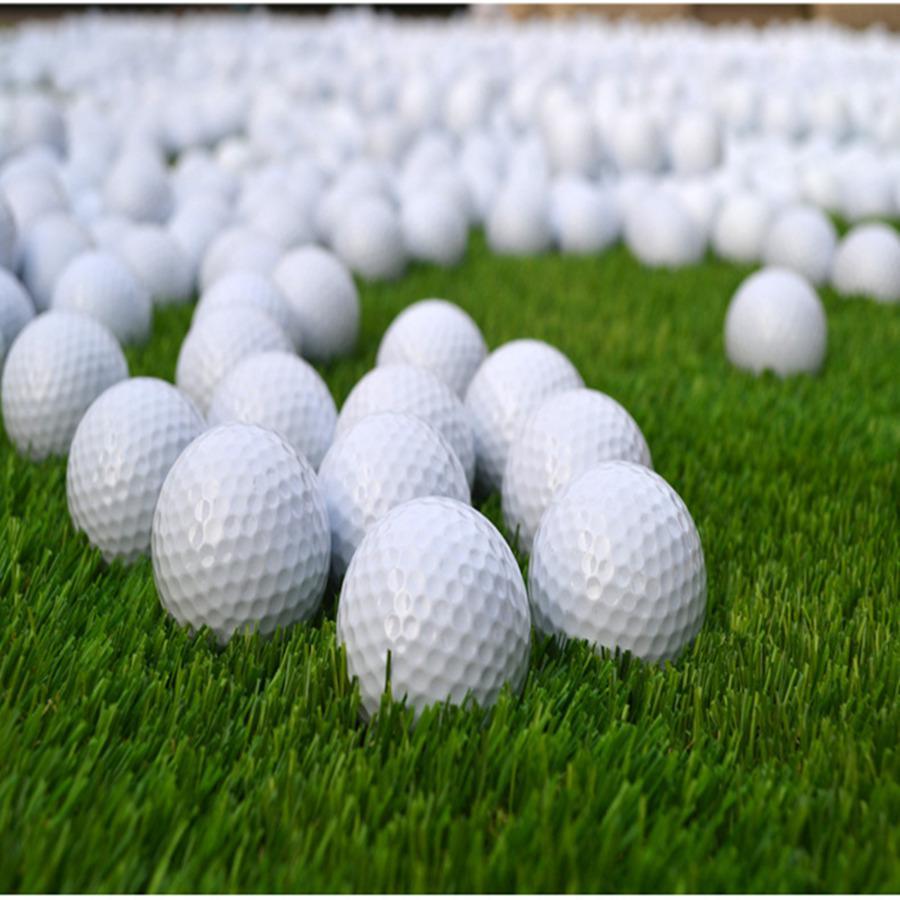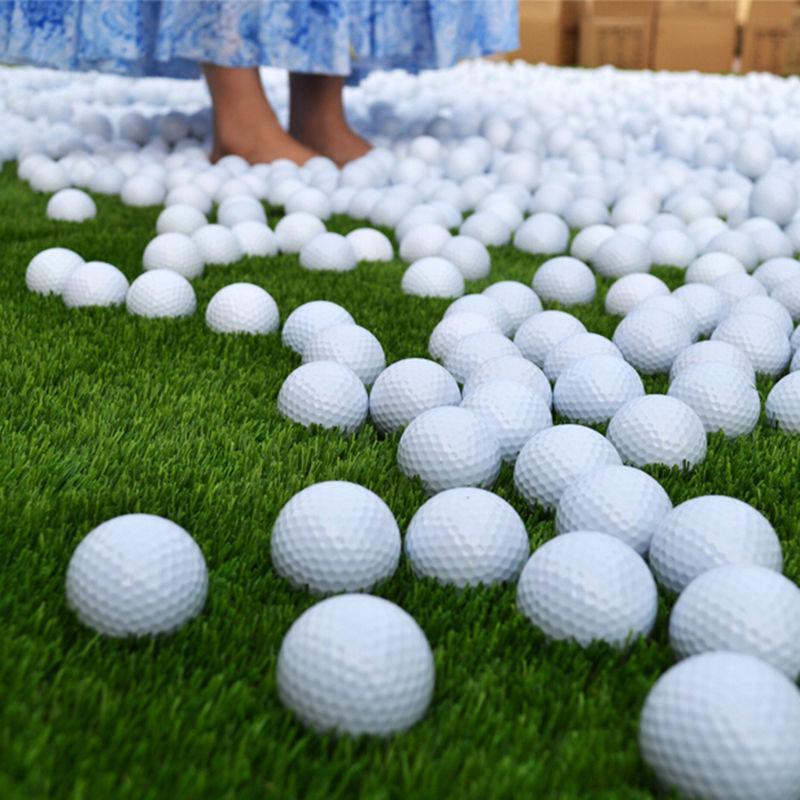The first image is the image on the left, the second image is the image on the right. Considering the images on both sides, is "Lettering is visible on some of the golf balls in one of the images." valid? Answer yes or no. No. The first image is the image on the left, the second image is the image on the right. For the images shown, is this caption "Both images show only white balls on green turf, with no logos or other markings on them." true? Answer yes or no. Yes. 